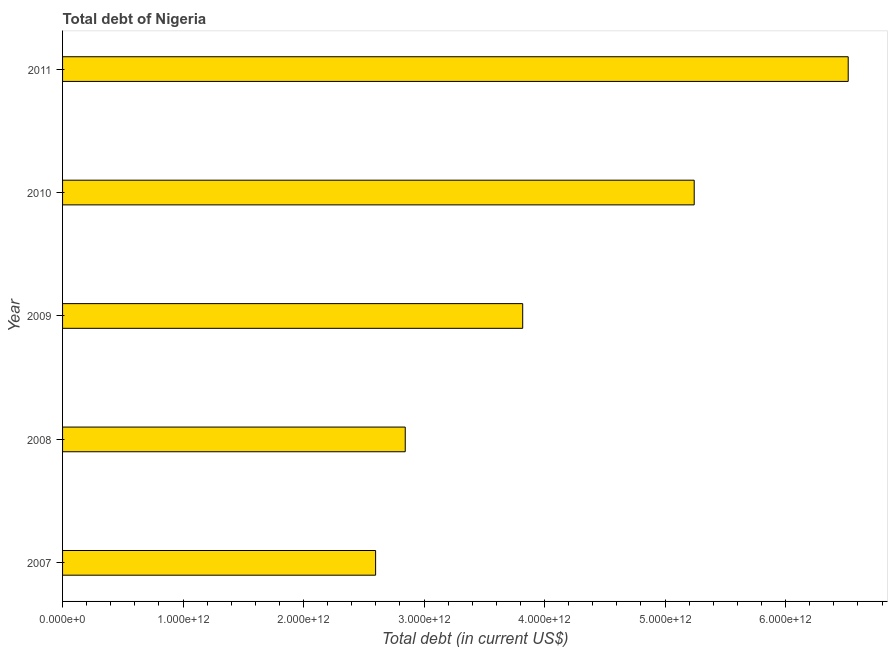Does the graph contain grids?
Keep it short and to the point. No. What is the title of the graph?
Give a very brief answer. Total debt of Nigeria. What is the label or title of the X-axis?
Offer a terse response. Total debt (in current US$). What is the total debt in 2010?
Your answer should be compact. 5.24e+12. Across all years, what is the maximum total debt?
Offer a very short reply. 6.52e+12. Across all years, what is the minimum total debt?
Your response must be concise. 2.60e+12. What is the sum of the total debt?
Give a very brief answer. 2.10e+13. What is the difference between the total debt in 2008 and 2011?
Provide a short and direct response. -3.68e+12. What is the average total debt per year?
Ensure brevity in your answer.  4.20e+12. What is the median total debt?
Give a very brief answer. 3.82e+12. In how many years, is the total debt greater than 1000000000000 US$?
Keep it short and to the point. 5. Do a majority of the years between 2009 and 2007 (inclusive) have total debt greater than 4400000000000 US$?
Make the answer very short. Yes. What is the ratio of the total debt in 2008 to that in 2010?
Give a very brief answer. 0.54. What is the difference between the highest and the second highest total debt?
Your answer should be very brief. 1.28e+12. Is the sum of the total debt in 2007 and 2011 greater than the maximum total debt across all years?
Your answer should be very brief. Yes. What is the difference between the highest and the lowest total debt?
Give a very brief answer. 3.92e+12. In how many years, is the total debt greater than the average total debt taken over all years?
Offer a very short reply. 2. How many bars are there?
Offer a terse response. 5. What is the difference between two consecutive major ticks on the X-axis?
Give a very brief answer. 1.00e+12. What is the Total debt (in current US$) in 2007?
Your answer should be compact. 2.60e+12. What is the Total debt (in current US$) of 2008?
Offer a terse response. 2.84e+12. What is the Total debt (in current US$) of 2009?
Offer a very short reply. 3.82e+12. What is the Total debt (in current US$) of 2010?
Offer a very short reply. 5.24e+12. What is the Total debt (in current US$) in 2011?
Make the answer very short. 6.52e+12. What is the difference between the Total debt (in current US$) in 2007 and 2008?
Keep it short and to the point. -2.46e+11. What is the difference between the Total debt (in current US$) in 2007 and 2009?
Your answer should be compact. -1.22e+12. What is the difference between the Total debt (in current US$) in 2007 and 2010?
Offer a terse response. -2.64e+12. What is the difference between the Total debt (in current US$) in 2007 and 2011?
Provide a succinct answer. -3.92e+12. What is the difference between the Total debt (in current US$) in 2008 and 2009?
Offer a very short reply. -9.75e+11. What is the difference between the Total debt (in current US$) in 2008 and 2010?
Your response must be concise. -2.40e+12. What is the difference between the Total debt (in current US$) in 2008 and 2011?
Your response must be concise. -3.68e+12. What is the difference between the Total debt (in current US$) in 2009 and 2010?
Your answer should be compact. -1.42e+12. What is the difference between the Total debt (in current US$) in 2009 and 2011?
Your response must be concise. -2.70e+12. What is the difference between the Total debt (in current US$) in 2010 and 2011?
Your answer should be very brief. -1.28e+12. What is the ratio of the Total debt (in current US$) in 2007 to that in 2008?
Give a very brief answer. 0.91. What is the ratio of the Total debt (in current US$) in 2007 to that in 2009?
Make the answer very short. 0.68. What is the ratio of the Total debt (in current US$) in 2007 to that in 2010?
Offer a very short reply. 0.5. What is the ratio of the Total debt (in current US$) in 2007 to that in 2011?
Offer a very short reply. 0.4. What is the ratio of the Total debt (in current US$) in 2008 to that in 2009?
Provide a short and direct response. 0.74. What is the ratio of the Total debt (in current US$) in 2008 to that in 2010?
Provide a succinct answer. 0.54. What is the ratio of the Total debt (in current US$) in 2008 to that in 2011?
Keep it short and to the point. 0.44. What is the ratio of the Total debt (in current US$) in 2009 to that in 2010?
Offer a terse response. 0.73. What is the ratio of the Total debt (in current US$) in 2009 to that in 2011?
Provide a succinct answer. 0.59. What is the ratio of the Total debt (in current US$) in 2010 to that in 2011?
Make the answer very short. 0.8. 